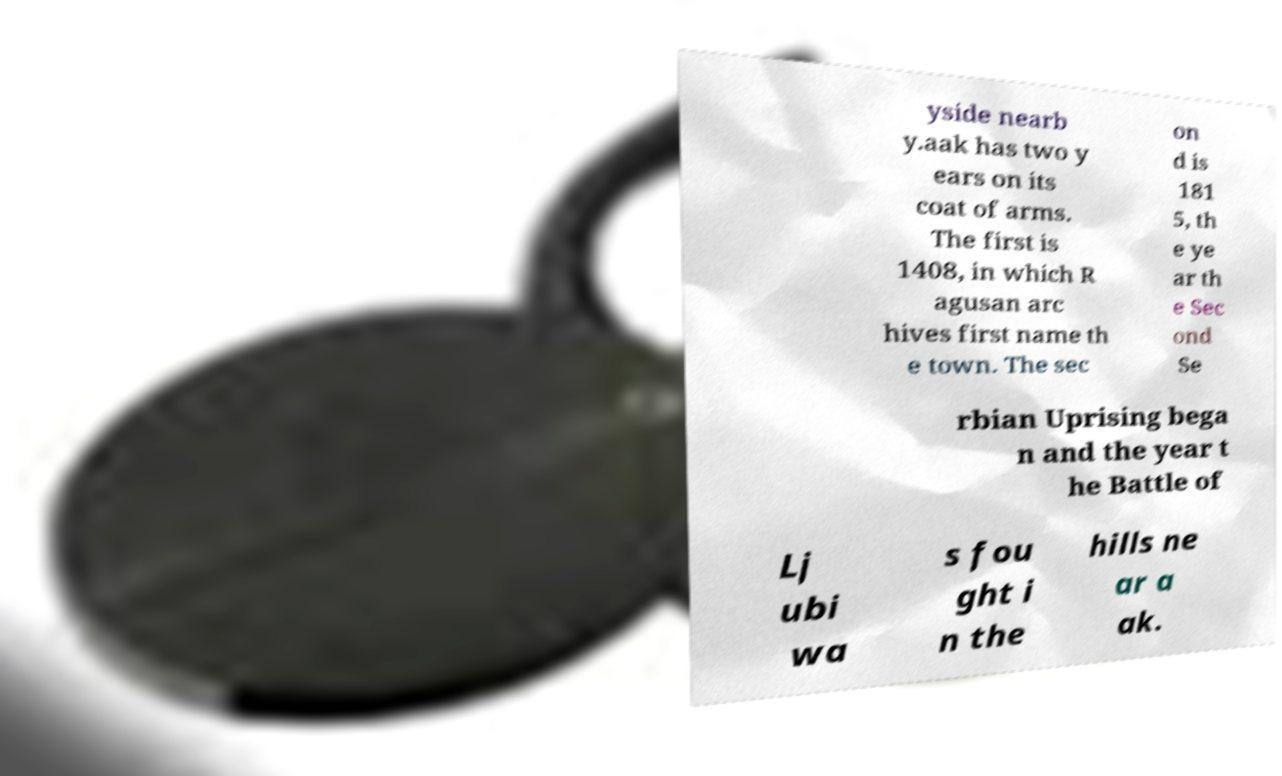There's text embedded in this image that I need extracted. Can you transcribe it verbatim? yside nearb y.aak has two y ears on its coat of arms. The first is 1408, in which R agusan arc hives first name th e town. The sec on d is 181 5, th e ye ar th e Sec ond Se rbian Uprising bega n and the year t he Battle of Lj ubi wa s fou ght i n the hills ne ar a ak. 